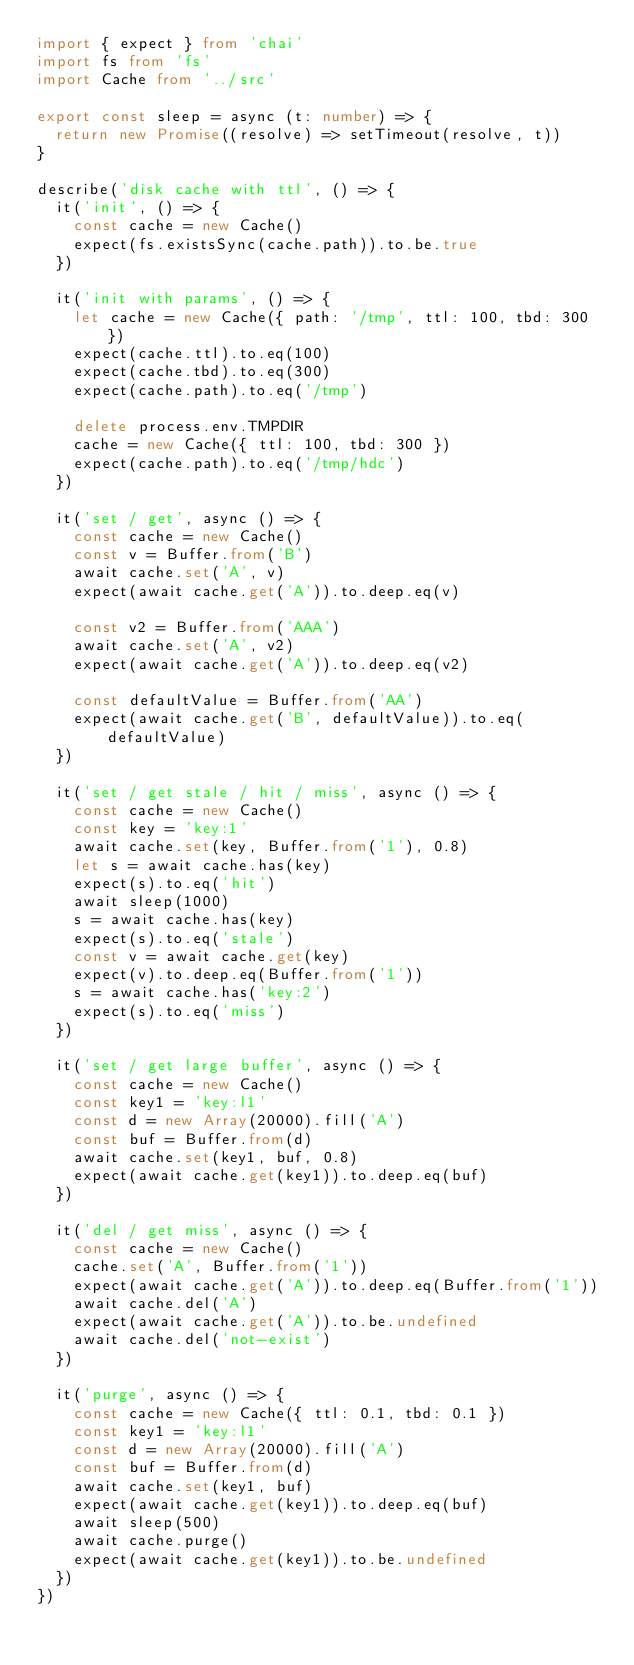Convert code to text. <code><loc_0><loc_0><loc_500><loc_500><_TypeScript_>import { expect } from 'chai'
import fs from 'fs'
import Cache from '../src'

export const sleep = async (t: number) => {
  return new Promise((resolve) => setTimeout(resolve, t))
}

describe('disk cache with ttl', () => {
  it('init', () => {
    const cache = new Cache()
    expect(fs.existsSync(cache.path)).to.be.true
  })

  it('init with params', () => {
    let cache = new Cache({ path: '/tmp', ttl: 100, tbd: 300 })
    expect(cache.ttl).to.eq(100)
    expect(cache.tbd).to.eq(300)
    expect(cache.path).to.eq('/tmp')

    delete process.env.TMPDIR
    cache = new Cache({ ttl: 100, tbd: 300 })
    expect(cache.path).to.eq('/tmp/hdc')
  })

  it('set / get', async () => {
    const cache = new Cache()
    const v = Buffer.from('B')
    await cache.set('A', v)
    expect(await cache.get('A')).to.deep.eq(v)

    const v2 = Buffer.from('AAA')
    await cache.set('A', v2)
    expect(await cache.get('A')).to.deep.eq(v2)

    const defaultValue = Buffer.from('AA')
    expect(await cache.get('B', defaultValue)).to.eq(defaultValue)
  })

  it('set / get stale / hit / miss', async () => {
    const cache = new Cache()
    const key = 'key:1'
    await cache.set(key, Buffer.from('1'), 0.8)
    let s = await cache.has(key)
    expect(s).to.eq('hit')
    await sleep(1000)
    s = await cache.has(key)
    expect(s).to.eq('stale')
    const v = await cache.get(key)
    expect(v).to.deep.eq(Buffer.from('1'))
    s = await cache.has('key:2')
    expect(s).to.eq('miss')
  })

  it('set / get large buffer', async () => {
    const cache = new Cache()
    const key1 = 'key:l1'
    const d = new Array(20000).fill('A')
    const buf = Buffer.from(d)
    await cache.set(key1, buf, 0.8)
    expect(await cache.get(key1)).to.deep.eq(buf)
  })

  it('del / get miss', async () => {
    const cache = new Cache()
    cache.set('A', Buffer.from('1'))
    expect(await cache.get('A')).to.deep.eq(Buffer.from('1'))
    await cache.del('A')
    expect(await cache.get('A')).to.be.undefined
    await cache.del('not-exist')
  })

  it('purge', async () => {
    const cache = new Cache({ ttl: 0.1, tbd: 0.1 })
    const key1 = 'key:l1'
    const d = new Array(20000).fill('A')
    const buf = Buffer.from(d)
    await cache.set(key1, buf)
    expect(await cache.get(key1)).to.deep.eq(buf)
    await sleep(500)
    await cache.purge()
    expect(await cache.get(key1)).to.be.undefined
  })
})
</code> 